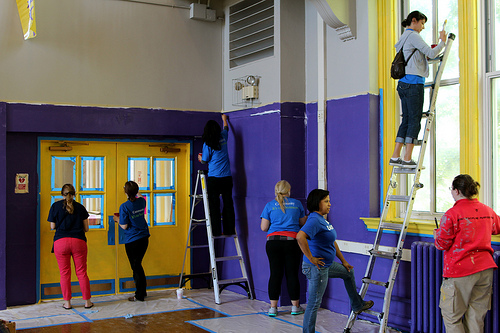<image>
Is there a woman on the ladder? Yes. Looking at the image, I can see the woman is positioned on top of the ladder, with the ladder providing support. 